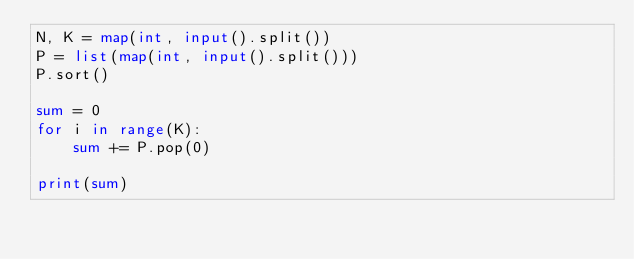<code> <loc_0><loc_0><loc_500><loc_500><_Python_>N, K = map(int, input().split())
P = list(map(int, input().split()))
P.sort()

sum = 0
for i in range(K):
    sum += P.pop(0)

print(sum)</code> 